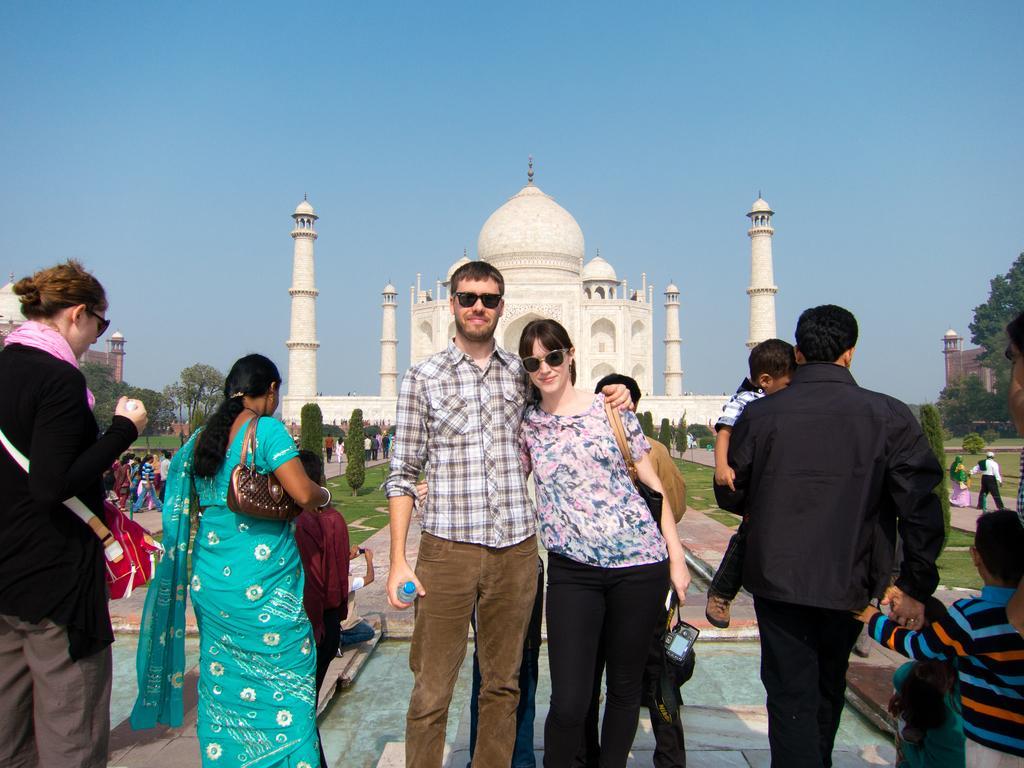Please provide a concise description of this image. In this image I can see number of people are standing. I can see few of them are wearing shades and few of them are carrying bags. I can also see smile on few faces and here I can see she is holding a camera and he is holding a bottle. In the background I can see number of trees, few buildings, Taj Mahal and sky. 